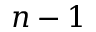Convert formula to latex. <formula><loc_0><loc_0><loc_500><loc_500>n - 1</formula> 